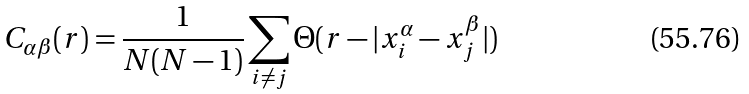Convert formula to latex. <formula><loc_0><loc_0><loc_500><loc_500>C _ { \alpha \beta } ( r ) = \frac { 1 } { N ( N - 1 ) } \sum _ { i \neq j } \Theta ( r - | x _ { i } ^ { \alpha } - x _ { j } ^ { \beta } | )</formula> 